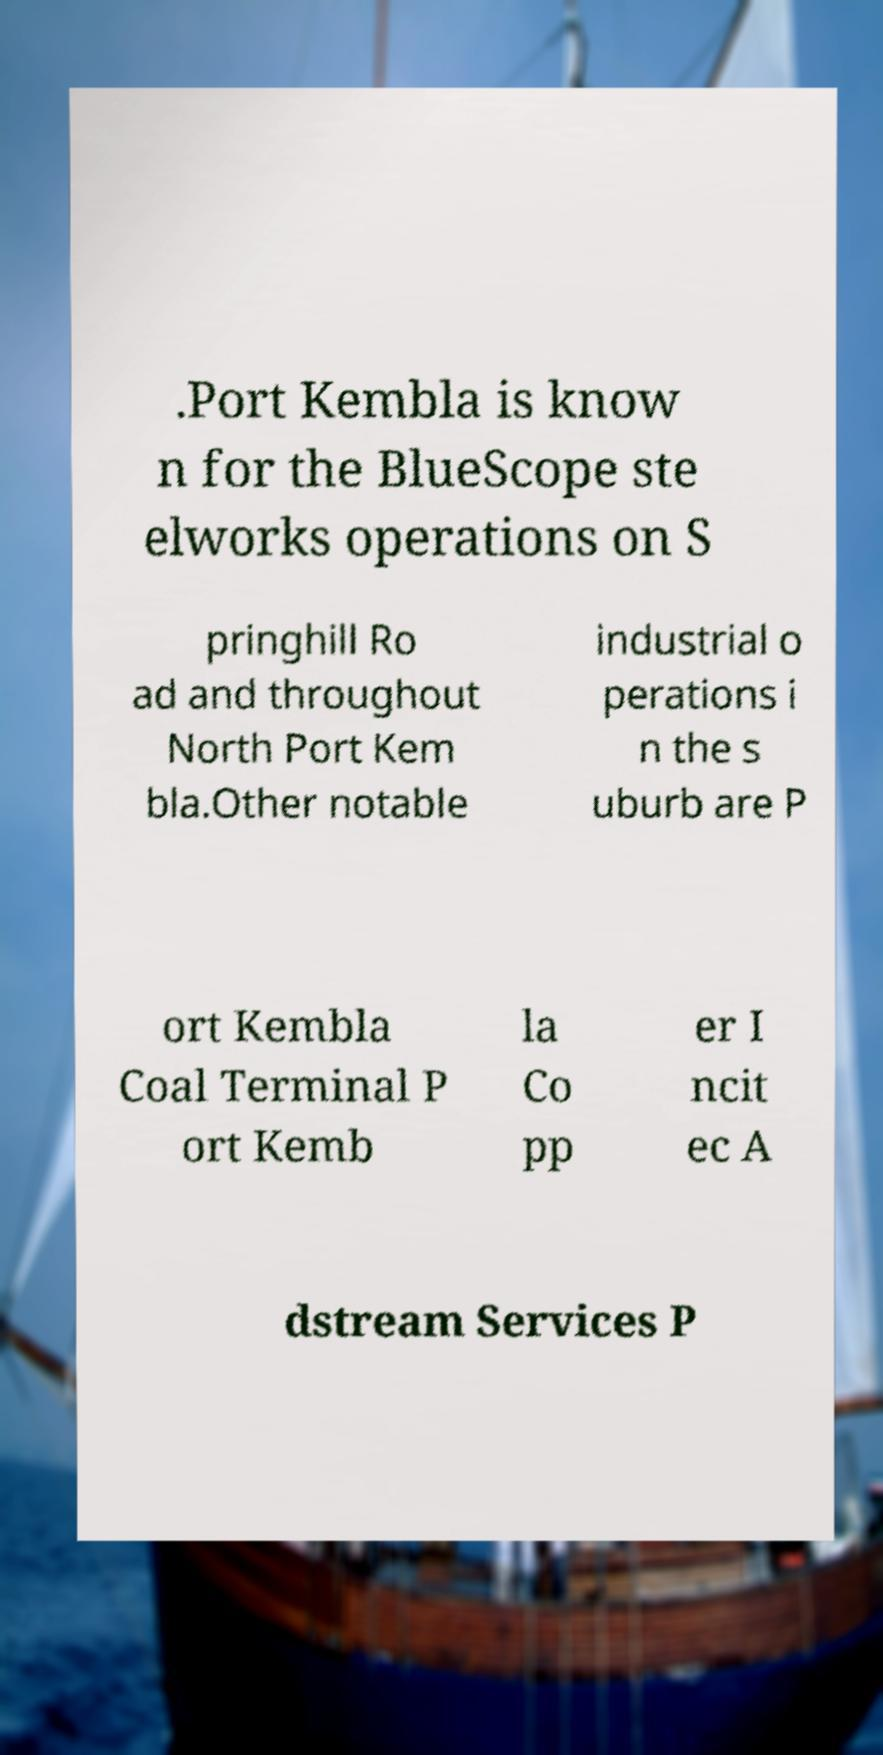For documentation purposes, I need the text within this image transcribed. Could you provide that? .Port Kembla is know n for the BlueScope ste elworks operations on S pringhill Ro ad and throughout North Port Kem bla.Other notable industrial o perations i n the s uburb are P ort Kembla Coal Terminal P ort Kemb la Co pp er I ncit ec A dstream Services P 